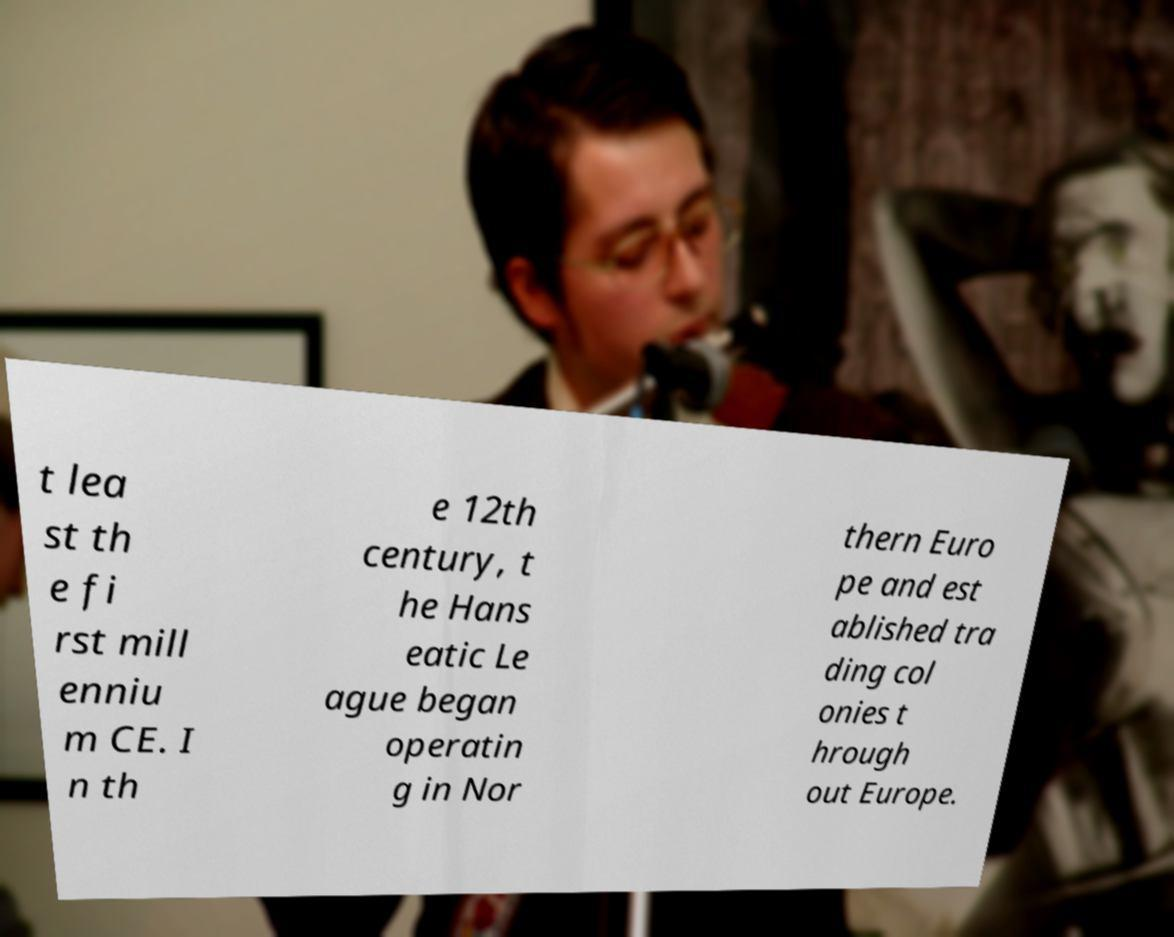I need the written content from this picture converted into text. Can you do that? t lea st th e fi rst mill enniu m CE. I n th e 12th century, t he Hans eatic Le ague began operatin g in Nor thern Euro pe and est ablished tra ding col onies t hrough out Europe. 